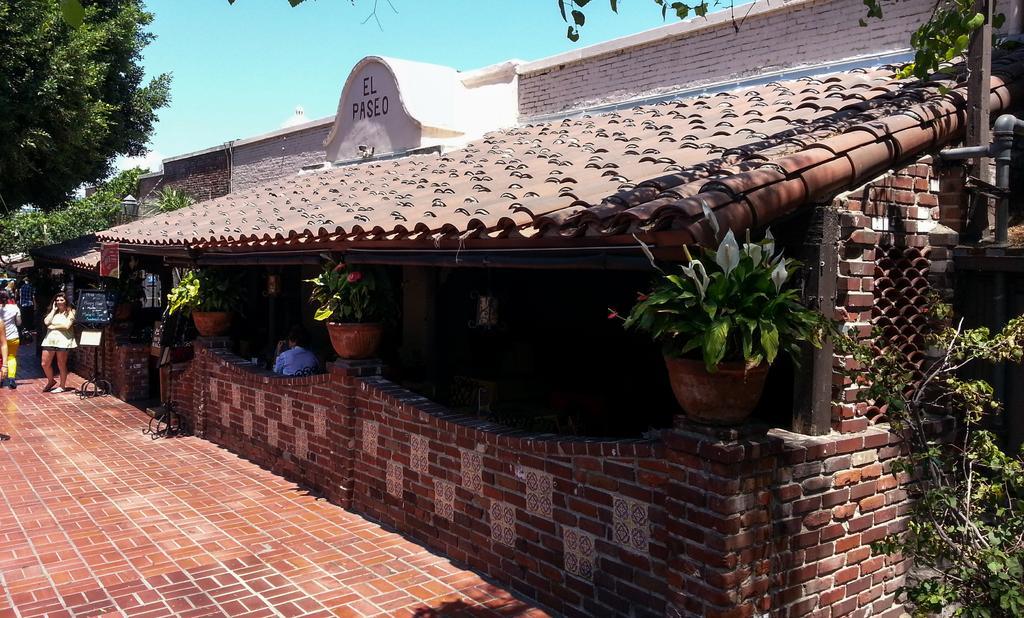Could you give a brief overview of what you see in this image? In this image I can see a person standing wearing white color dress. I can also see few plants in green color and sky in blue color. 